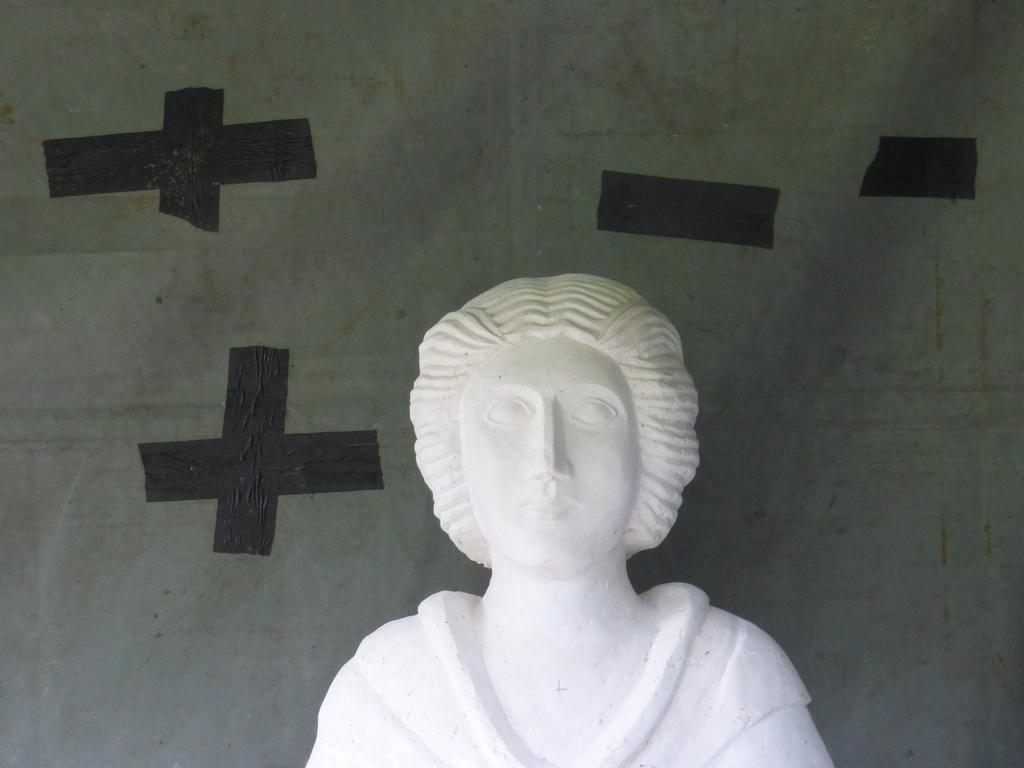What is the main subject of the image? There is a sculpture in the image. Where is the sculpture located in relation to other elements in the image? The sculpture is in front of a wall. What type of credit card is being used to purchase the sculpture in the image? There is no credit card or purchase activity depicted in the image; it only shows a sculpture in front of a wall. 